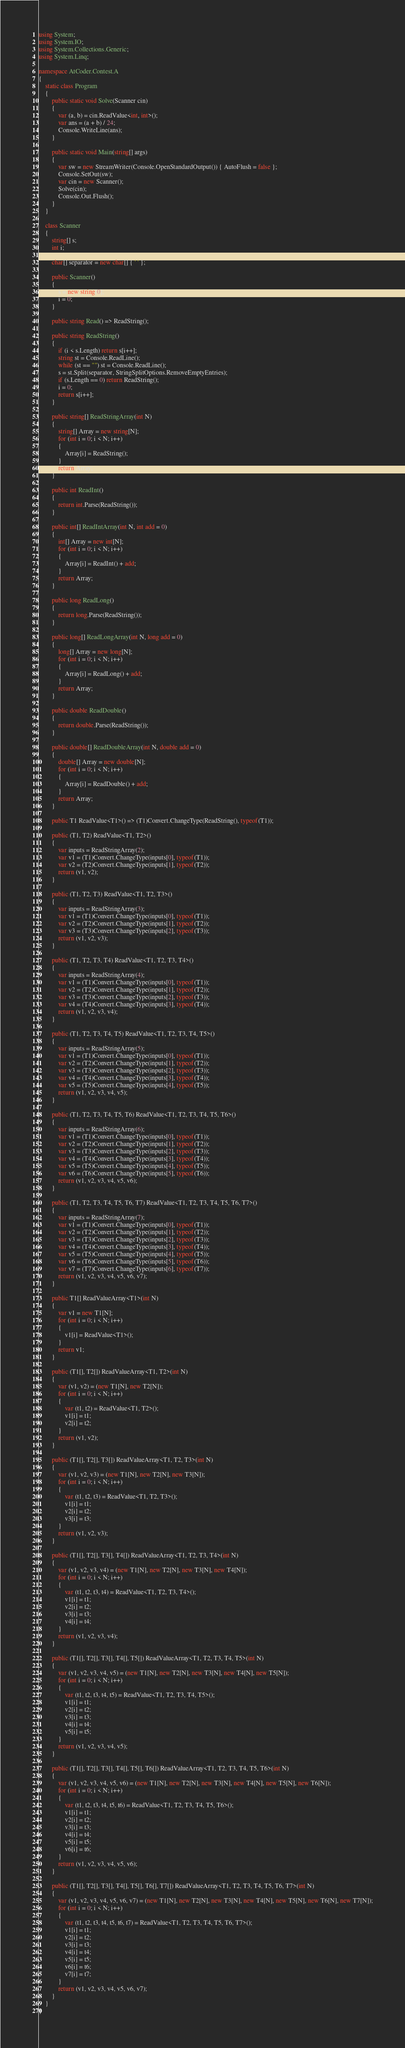Convert code to text. <code><loc_0><loc_0><loc_500><loc_500><_C#_>using System;
using System.IO;
using System.Collections.Generic;
using System.Linq;

namespace AtCoder.Contest.A
{
	static class Program
	{
		public static void Solve(Scanner cin)
		{
			var (a, b) = cin.ReadValue<int, int>();
			var ans = (a + b) / 24;
			Console.WriteLine(ans);
		}

		public static void Main(string[] args)
		{
			var sw = new StreamWriter(Console.OpenStandardOutput()) { AutoFlush = false };
			Console.SetOut(sw);
			var cin = new Scanner();
			Solve(cin);
			Console.Out.Flush();
		}
	}

	class Scanner
	{
		string[] s;
		int i;

		char[] separator = new char[] { ' ' };

		public Scanner()
		{
			s = new string[0];
			i = 0;
		}

		public string Read() => ReadString();

		public string ReadString()
		{
			if (i < s.Length) return s[i++];
			string st = Console.ReadLine();
			while (st == "") st = Console.ReadLine();
			s = st.Split(separator, StringSplitOptions.RemoveEmptyEntries);
			if (s.Length == 0) return ReadString();
			i = 0;
			return s[i++];
		}

		public string[] ReadStringArray(int N)
		{
			string[] Array = new string[N];
			for (int i = 0; i < N; i++)
			{
				Array[i] = ReadString();
			}
			return Array;
		}

		public int ReadInt()
		{
			return int.Parse(ReadString());
		}

		public int[] ReadIntArray(int N, int add = 0)
		{
			int[] Array = new int[N];
			for (int i = 0; i < N; i++)
			{
				Array[i] = ReadInt() + add;
			}
			return Array;
		}

		public long ReadLong()
		{
			return long.Parse(ReadString());
		}

		public long[] ReadLongArray(int N, long add = 0)
		{
			long[] Array = new long[N];
			for (int i = 0; i < N; i++)
			{
				Array[i] = ReadLong() + add;
			}
			return Array;
		}

		public double ReadDouble()
		{
			return double.Parse(ReadString());
		}

		public double[] ReadDoubleArray(int N, double add = 0)
		{
			double[] Array = new double[N];
			for (int i = 0; i < N; i++)
			{
				Array[i] = ReadDouble() + add;
			}
			return Array;
		}

		public T1 ReadValue<T1>() => (T1)Convert.ChangeType(ReadString(), typeof(T1));

		public (T1, T2) ReadValue<T1, T2>()
		{
			var inputs = ReadStringArray(2);
			var v1 = (T1)Convert.ChangeType(inputs[0], typeof(T1));
			var v2 = (T2)Convert.ChangeType(inputs[1], typeof(T2));
			return (v1, v2);
		}

		public (T1, T2, T3) ReadValue<T1, T2, T3>()
		{
			var inputs = ReadStringArray(3);
			var v1 = (T1)Convert.ChangeType(inputs[0], typeof(T1));
			var v2 = (T2)Convert.ChangeType(inputs[1], typeof(T2));
			var v3 = (T3)Convert.ChangeType(inputs[2], typeof(T3));
			return (v1, v2, v3);
		}

		public (T1, T2, T3, T4) ReadValue<T1, T2, T3, T4>()
		{
			var inputs = ReadStringArray(4);
			var v1 = (T1)Convert.ChangeType(inputs[0], typeof(T1));
			var v2 = (T2)Convert.ChangeType(inputs[1], typeof(T2));
			var v3 = (T3)Convert.ChangeType(inputs[2], typeof(T3));
			var v4 = (T4)Convert.ChangeType(inputs[3], typeof(T4));
			return (v1, v2, v3, v4);
		}

		public (T1, T2, T3, T4, T5) ReadValue<T1, T2, T3, T4, T5>()
		{
			var inputs = ReadStringArray(5);
			var v1 = (T1)Convert.ChangeType(inputs[0], typeof(T1));
			var v2 = (T2)Convert.ChangeType(inputs[1], typeof(T2));
			var v3 = (T3)Convert.ChangeType(inputs[2], typeof(T3));
			var v4 = (T4)Convert.ChangeType(inputs[3], typeof(T4));
			var v5 = (T5)Convert.ChangeType(inputs[4], typeof(T5));
			return (v1, v2, v3, v4, v5);
		}

		public (T1, T2, T3, T4, T5, T6) ReadValue<T1, T2, T3, T4, T5, T6>()
		{
			var inputs = ReadStringArray(6);
			var v1 = (T1)Convert.ChangeType(inputs[0], typeof(T1));
			var v2 = (T2)Convert.ChangeType(inputs[1], typeof(T2));
			var v3 = (T3)Convert.ChangeType(inputs[2], typeof(T3));
			var v4 = (T4)Convert.ChangeType(inputs[3], typeof(T4));
			var v5 = (T5)Convert.ChangeType(inputs[4], typeof(T5));
			var v6 = (T6)Convert.ChangeType(inputs[5], typeof(T6));
			return (v1, v2, v3, v4, v5, v6);
		}

		public (T1, T2, T3, T4, T5, T6, T7) ReadValue<T1, T2, T3, T4, T5, T6, T7>()
		{
			var inputs = ReadStringArray(7);
			var v1 = (T1)Convert.ChangeType(inputs[0], typeof(T1));
			var v2 = (T2)Convert.ChangeType(inputs[1], typeof(T2));
			var v3 = (T3)Convert.ChangeType(inputs[2], typeof(T3));
			var v4 = (T4)Convert.ChangeType(inputs[3], typeof(T4));
			var v5 = (T5)Convert.ChangeType(inputs[4], typeof(T5));
			var v6 = (T6)Convert.ChangeType(inputs[5], typeof(T6));
			var v7 = (T7)Convert.ChangeType(inputs[6], typeof(T7));
			return (v1, v2, v3, v4, v5, v6, v7);
		}

		public T1[] ReadValueArray<T1>(int N)
		{
			var v1 = new T1[N];
			for (int i = 0; i < N; i++)
			{
				v1[i] = ReadValue<T1>();
			}
			return v1;
		}

		public (T1[], T2[]) ReadValueArray<T1, T2>(int N)
		{
			var (v1, v2) = (new T1[N], new T2[N]);
			for (int i = 0; i < N; i++)
			{
				var (t1, t2) = ReadValue<T1, T2>();
				v1[i] = t1;
				v2[i] = t2;
			}
			return (v1, v2);
		}

		public (T1[], T2[], T3[]) ReadValueArray<T1, T2, T3>(int N)
		{
			var (v1, v2, v3) = (new T1[N], new T2[N], new T3[N]);
			for (int i = 0; i < N; i++)
			{
				var (t1, t2, t3) = ReadValue<T1, T2, T3>();
				v1[i] = t1;
				v2[i] = t2;
				v3[i] = t3;
			}
			return (v1, v2, v3);
		}

		public (T1[], T2[], T3[], T4[]) ReadValueArray<T1, T2, T3, T4>(int N)
		{
			var (v1, v2, v3, v4) = (new T1[N], new T2[N], new T3[N], new T4[N]);
			for (int i = 0; i < N; i++)
			{
				var (t1, t2, t3, t4) = ReadValue<T1, T2, T3, T4>();
				v1[i] = t1;
				v2[i] = t2;
				v3[i] = t3;
				v4[i] = t4;
			}
			return (v1, v2, v3, v4);
		}

		public (T1[], T2[], T3[], T4[], T5[]) ReadValueArray<T1, T2, T3, T4, T5>(int N)
		{
			var (v1, v2, v3, v4, v5) = (new T1[N], new T2[N], new T3[N], new T4[N], new T5[N]);
			for (int i = 0; i < N; i++)
			{
				var (t1, t2, t3, t4, t5) = ReadValue<T1, T2, T3, T4, T5>();
				v1[i] = t1;
				v2[i] = t2;
				v3[i] = t3;
				v4[i] = t4;
				v5[i] = t5;
			}
			return (v1, v2, v3, v4, v5);
		}

		public (T1[], T2[], T3[], T4[], T5[], T6[]) ReadValueArray<T1, T2, T3, T4, T5, T6>(int N)
		{
			var (v1, v2, v3, v4, v5, v6) = (new T1[N], new T2[N], new T3[N], new T4[N], new T5[N], new T6[N]);
			for (int i = 0; i < N; i++)
			{
				var (t1, t2, t3, t4, t5, t6) = ReadValue<T1, T2, T3, T4, T5, T6>();
				v1[i] = t1;
				v2[i] = t2;
				v3[i] = t3;
				v4[i] = t4;
				v5[i] = t5;
				v6[i] = t6;
			}
			return (v1, v2, v3, v4, v5, v6);
		}

		public (T1[], T2[], T3[], T4[], T5[], T6[], T7[]) ReadValueArray<T1, T2, T3, T4, T5, T6, T7>(int N)
		{
			var (v1, v2, v3, v4, v5, v6, v7) = (new T1[N], new T2[N], new T3[N], new T4[N], new T5[N], new T6[N], new T7[N]);
			for (int i = 0; i < N; i++)
			{
				var (t1, t2, t3, t4, t5, t6, t7) = ReadValue<T1, T2, T3, T4, T5, T6, T7>();
				v1[i] = t1;
				v2[i] = t2;
				v3[i] = t3;
				v4[i] = t4;
				v5[i] = t5;
				v6[i] = t6;
				v7[i] = t7;
			}
			return (v1, v2, v3, v4, v5, v6, v7);
		}
	}
}
</code> 